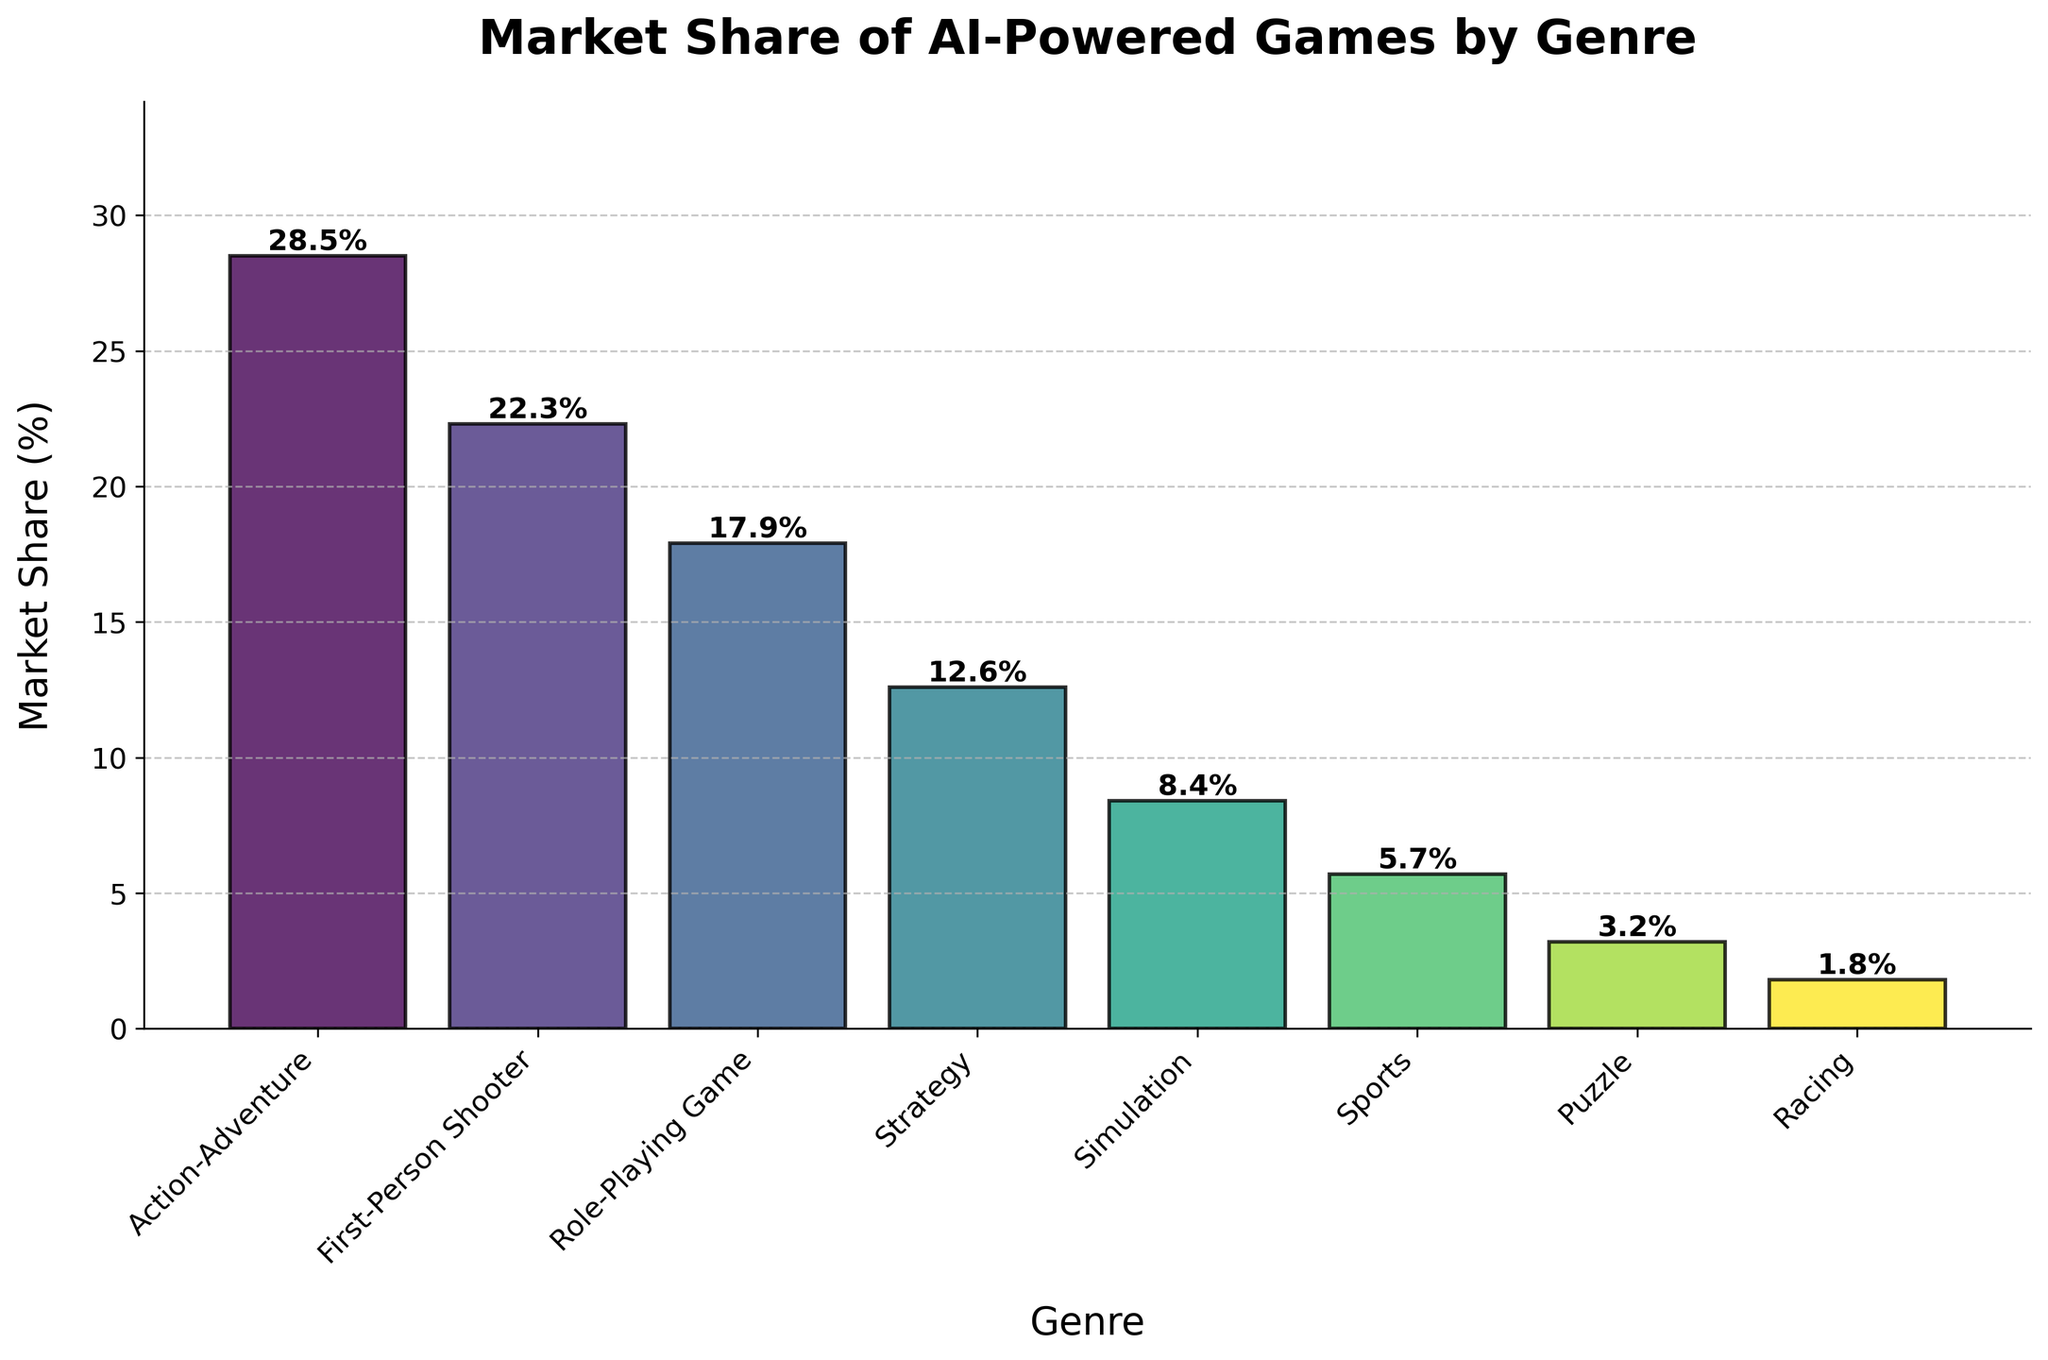Which genre has the highest market share? By examining the figure, you can see that the Action-Adventure genre has the tallest bar, indicating it has the highest market share.
Answer: Action-Adventure Which genre has the lowest market share? By observing the figure, you can see that the Racing genre has the shortest bar, indicating it has the lowest market share.
Answer: Racing What is the combined market share of First-Person Shooter and Role-Playing Game genres? Adding the market shares of First-Person Shooter (22.3%) and Role-Playing Game (17.9%) gives 40.2%.
Answer: 40.2% How much more market share does the Action-Adventure genre have compared to the Strategy genre? Subtract the market share of the Strategy genre (12.6%) from the market share of the Action-Adventure genre (28.5%). The difference is 28.5% - 12.6% = 15.9%.
Answer: 15.9% Which genres have a market share greater than 20%? By examining the figure, you can identify that the Action-Adventure and First-Person Shooter genres have bars taller than the 20% mark.
Answer: Action-Adventure, First-Person Shooter What is the average market share of the genres with market shares below 10%? The genres with market shares below 10% are Simulation (8.4%), Sports (5.7%), Puzzle (3.2%), and Racing (1.8%). Calculate the average as (8.4 + 5.7 + 3.2 + 1.8) / 4 = 19.1 / 4 = 4.775%.
Answer: 4.775% How many genres have a market share less than 10%? Count the number of bars that have heights less than the 10% mark. These are Simulation, Sports, Puzzle, and Racing, totaling 4 genres.
Answer: 4 What is the median market share among all the genres? To find the median, first list all the market share values in ascending order: 1.8%, 3.2%, 5.7%, 8.4%, 12.6%, 17.9%, 22.3%, 28.5%. The median is the average of the 4th and 5th values: (8.4 + 12.6) / 2 = 21 / 2 = 10.5%.
Answer: 10.5% What is the difference between the highest and lowest market shares? Subtract the lowest market share (Racing, 1.8%) from the highest market share (Action-Adventure, 28.5%). The difference is 28.5% - 1.8% = 26.7%.
Answer: 26.7% 